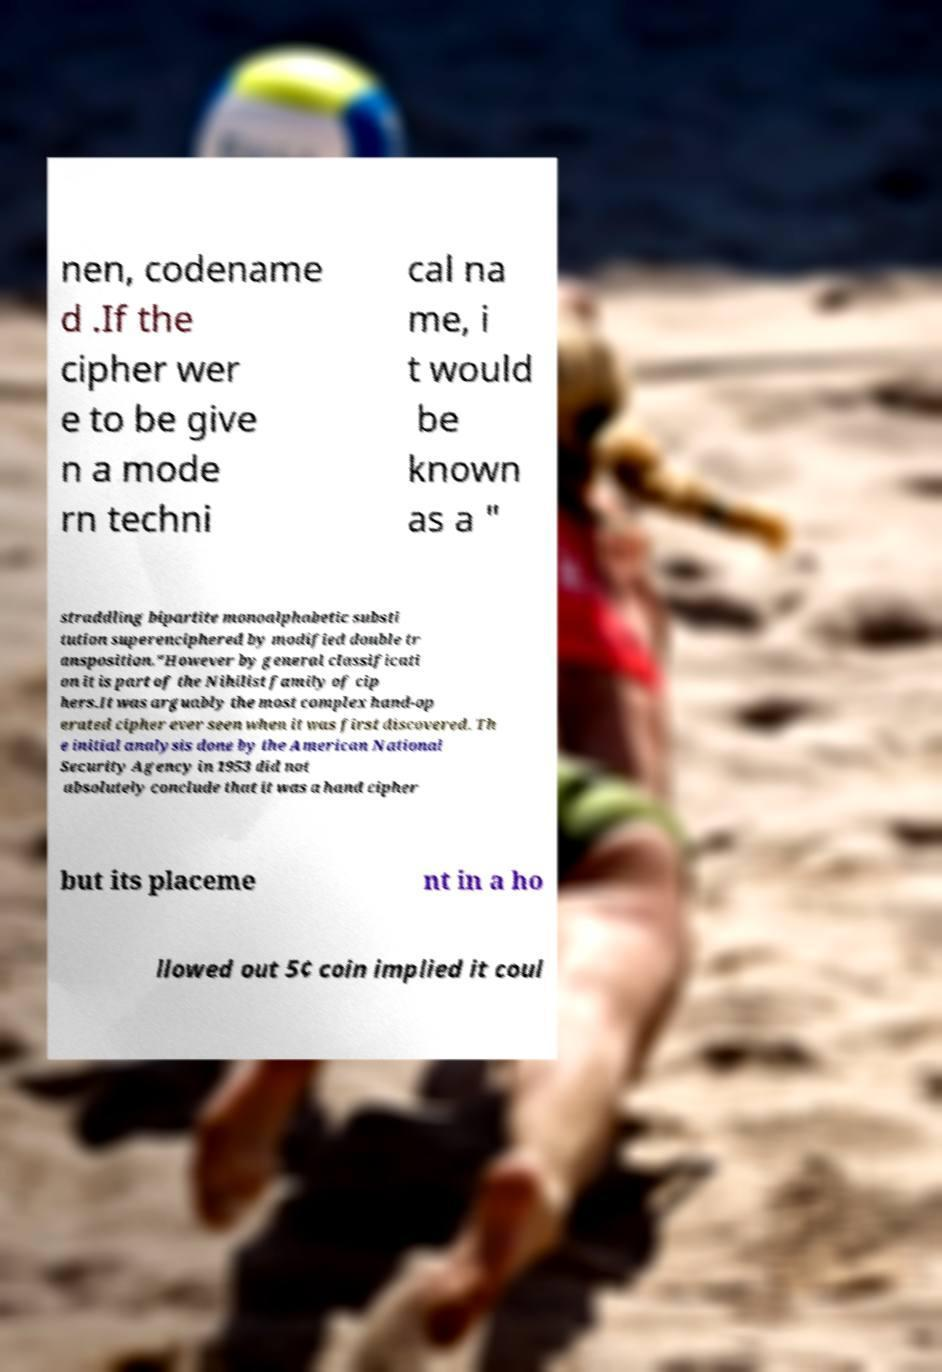Can you read and provide the text displayed in the image?This photo seems to have some interesting text. Can you extract and type it out for me? nen, codename d .If the cipher wer e to be give n a mode rn techni cal na me, i t would be known as a " straddling bipartite monoalphabetic substi tution superenciphered by modified double tr ansposition."However by general classificati on it is part of the Nihilist family of cip hers.It was arguably the most complex hand-op erated cipher ever seen when it was first discovered. Th e initial analysis done by the American National Security Agency in 1953 did not absolutely conclude that it was a hand cipher but its placeme nt in a ho llowed out 5¢ coin implied it coul 